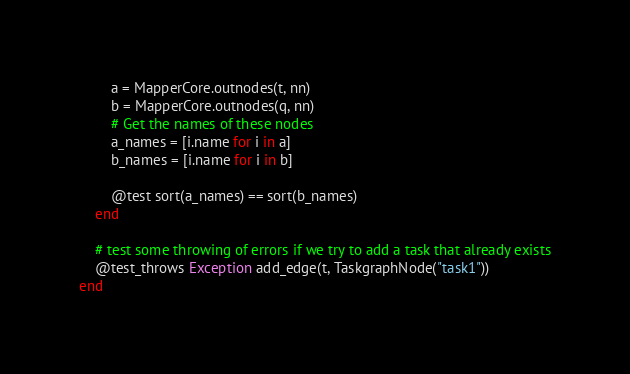Convert code to text. <code><loc_0><loc_0><loc_500><loc_500><_Julia_>        a = MapperCore.outnodes(t, nn)
        b = MapperCore.outnodes(q, nn)
        # Get the names of these nodes
        a_names = [i.name for i in a]
        b_names = [i.name for i in b]

        @test sort(a_names) == sort(b_names)
    end

    # test some throwing of errors if we try to add a task that already exists
    @test_throws Exception add_edge(t, TaskgraphNode("task1"))
end
</code> 